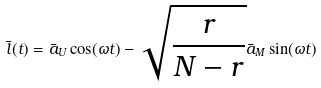<formula> <loc_0><loc_0><loc_500><loc_500>\bar { l } ( t ) = \bar { a } _ { U } \cos ( \omega t ) - \sqrt { \frac { r } { N - r } } \bar { a } _ { M } \sin ( \omega t )</formula> 